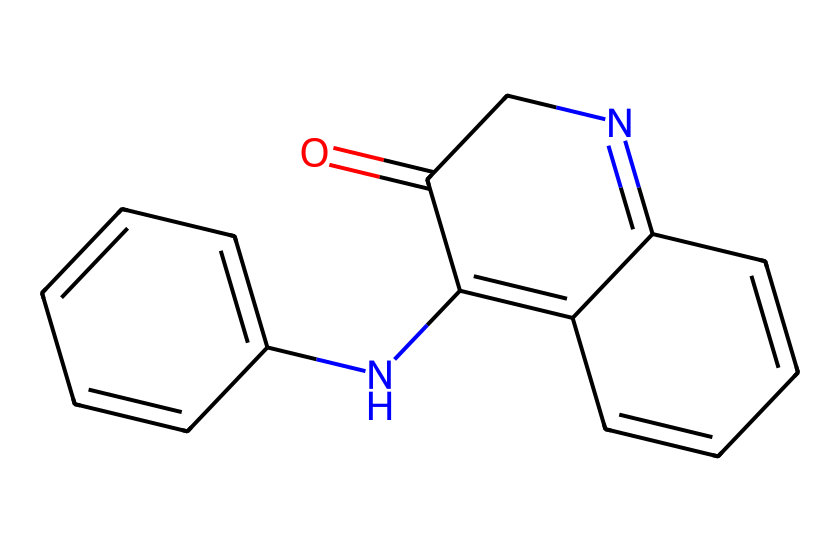What is the name of this chemical? The SMILES representation provided corresponds to the structure of indigo, which is a well-known natural dye used historically for textiles.
Answer: indigo How many nitrogen atoms are present in the molecule? Upon analyzing the structure from the SMILES notation, we can count two nitrogen atoms located within the cyclic portions of the indigo structure.
Answer: 2 How many rings are present in the chemical structure? The chemical structure has three interconnected rings based on the arrangement of carbon and nitrogen atoms indicated in the SMILES notation.
Answer: 3 What type of bonding predominates in this molecule? The molecule primarily exhibits covalent bonding, notably seen in the carbon-carbon and carbon-nitrogen connections, which are common in organic compounds like indigo.
Answer: covalent What feature in the structure contributes to its color properties? The extensive conjugated double bond system in the structure enhances light absorption at specific wavelengths, which is a characteristic of indigo responsible for its deep blue color.
Answer: conjugation Is this chemical considered aromatic? Analyzing the structure reveals that it contains alternating single and double bonds within at least two of its rings, fulfilling the criteria for aromaticity due to resonance stabilization.
Answer: yes What is the molecular formula for indigo? By counting the atoms of carbon, hydrogen, nitrogen, and oxygen from the SMILES representation, the molecular formula can be determined as C16H10N2O2.
Answer: C16H10N2O2 